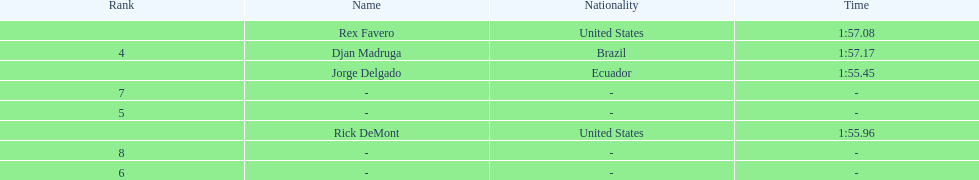Who was the last finisher from the us? Rex Favero. 